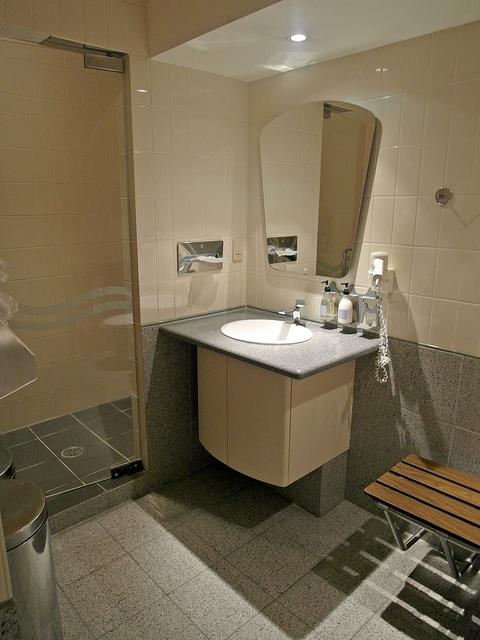What usually happens in this room?

Choices:
A) pool playing
B) sleeping
C) hand washing
D) cooking hand washing 